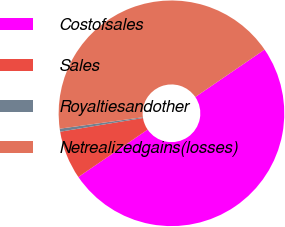<chart> <loc_0><loc_0><loc_500><loc_500><pie_chart><fcel>Costofsales<fcel>Sales<fcel>Royaltiesandother<fcel>Netrealizedgains(losses)<nl><fcel>50.0%<fcel>6.94%<fcel>0.43%<fcel>42.63%<nl></chart> 